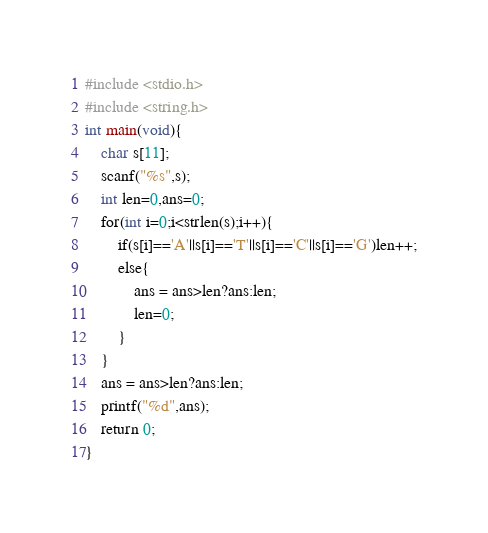Convert code to text. <code><loc_0><loc_0><loc_500><loc_500><_C_>#include <stdio.h>
#include <string.h>
int main(void){
	char s[11];
	scanf("%s",s);
	int len=0,ans=0;
	for(int i=0;i<strlen(s);i++){
		if(s[i]=='A'||s[i]=='T'||s[i]=='C'||s[i]=='G')len++;
		else{
			ans = ans>len?ans:len;
			len=0;
		}
	}
	ans = ans>len?ans:len;
	printf("%d",ans);
	return 0;
}</code> 